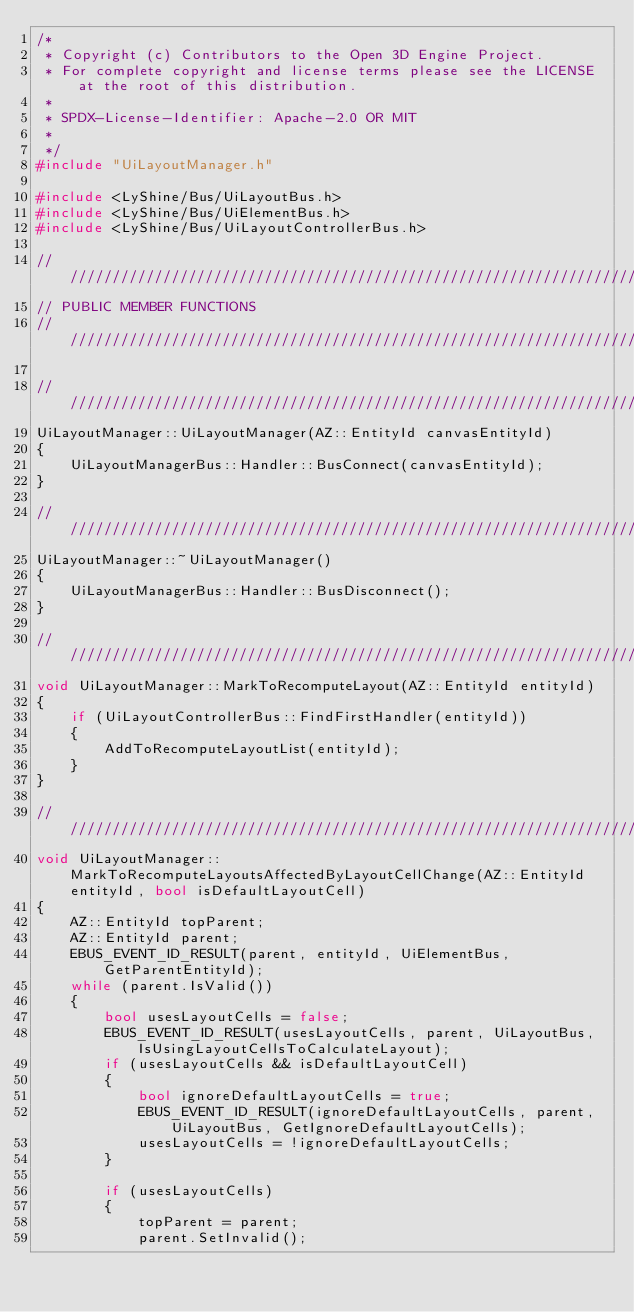<code> <loc_0><loc_0><loc_500><loc_500><_C++_>/*
 * Copyright (c) Contributors to the Open 3D Engine Project.
 * For complete copyright and license terms please see the LICENSE at the root of this distribution.
 *
 * SPDX-License-Identifier: Apache-2.0 OR MIT
 *
 */
#include "UiLayoutManager.h"

#include <LyShine/Bus/UiLayoutBus.h>
#include <LyShine/Bus/UiElementBus.h>
#include <LyShine/Bus/UiLayoutControllerBus.h>

////////////////////////////////////////////////////////////////////////////////////////////////////
// PUBLIC MEMBER FUNCTIONS
////////////////////////////////////////////////////////////////////////////////////////////////////

////////////////////////////////////////////////////////////////////////////////////////////////////
UiLayoutManager::UiLayoutManager(AZ::EntityId canvasEntityId)
{
    UiLayoutManagerBus::Handler::BusConnect(canvasEntityId);
}

////////////////////////////////////////////////////////////////////////////////////////////////////
UiLayoutManager::~UiLayoutManager()
{
    UiLayoutManagerBus::Handler::BusDisconnect();
}

////////////////////////////////////////////////////////////////////////////////////////////////////
void UiLayoutManager::MarkToRecomputeLayout(AZ::EntityId entityId)
{
    if (UiLayoutControllerBus::FindFirstHandler(entityId))
    {
        AddToRecomputeLayoutList(entityId);
    }
}

////////////////////////////////////////////////////////////////////////////////////////////////////
void UiLayoutManager::MarkToRecomputeLayoutsAffectedByLayoutCellChange(AZ::EntityId entityId, bool isDefaultLayoutCell)
{
    AZ::EntityId topParent;
    AZ::EntityId parent;
    EBUS_EVENT_ID_RESULT(parent, entityId, UiElementBus, GetParentEntityId);
    while (parent.IsValid())
    {
        bool usesLayoutCells = false;
        EBUS_EVENT_ID_RESULT(usesLayoutCells, parent, UiLayoutBus, IsUsingLayoutCellsToCalculateLayout);
        if (usesLayoutCells && isDefaultLayoutCell)
        {
            bool ignoreDefaultLayoutCells = true;
            EBUS_EVENT_ID_RESULT(ignoreDefaultLayoutCells, parent, UiLayoutBus, GetIgnoreDefaultLayoutCells);
            usesLayoutCells = !ignoreDefaultLayoutCells;
        }

        if (usesLayoutCells)
        {
            topParent = parent;
            parent.SetInvalid();</code> 